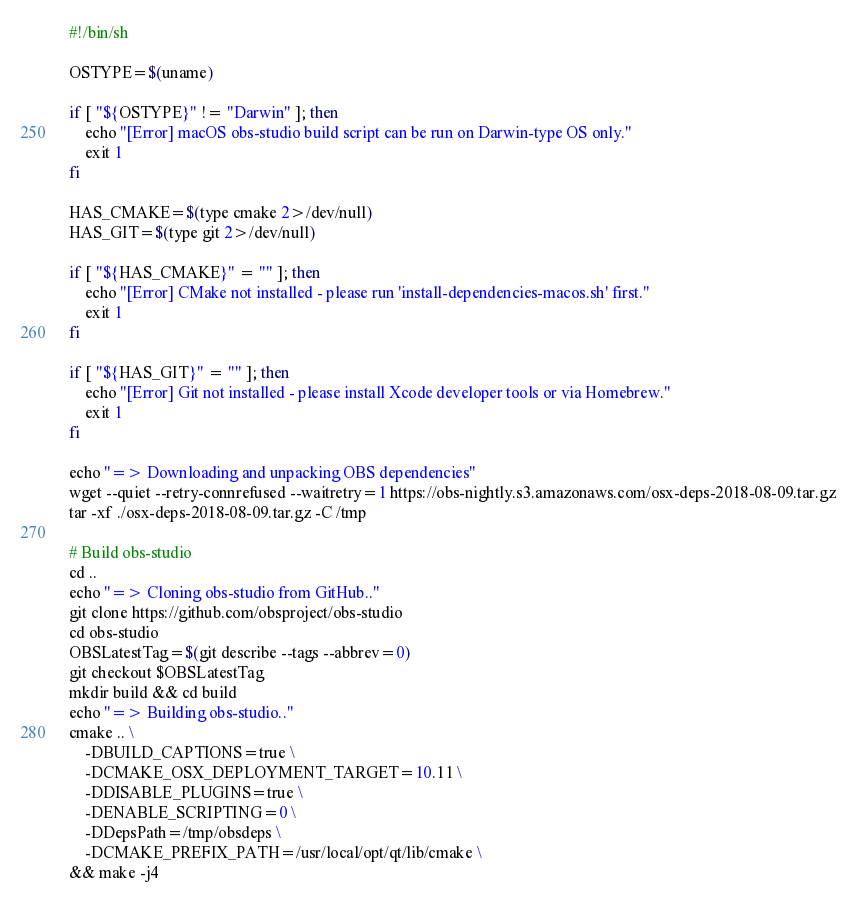<code> <loc_0><loc_0><loc_500><loc_500><_Bash_>#!/bin/sh

OSTYPE=$(uname)

if [ "${OSTYPE}" != "Darwin" ]; then
    echo "[Error] macOS obs-studio build script can be run on Darwin-type OS only."
    exit 1
fi

HAS_CMAKE=$(type cmake 2>/dev/null)
HAS_GIT=$(type git 2>/dev/null)

if [ "${HAS_CMAKE}" = "" ]; then
    echo "[Error] CMake not installed - please run 'install-dependencies-macos.sh' first."
    exit 1
fi

if [ "${HAS_GIT}" = "" ]; then
    echo "[Error] Git not installed - please install Xcode developer tools or via Homebrew."
    exit 1
fi

echo "=> Downloading and unpacking OBS dependencies"
wget --quiet --retry-connrefused --waitretry=1 https://obs-nightly.s3.amazonaws.com/osx-deps-2018-08-09.tar.gz
tar -xf ./osx-deps-2018-08-09.tar.gz -C /tmp

# Build obs-studio
cd ..
echo "=> Cloning obs-studio from GitHub.."
git clone https://github.com/obsproject/obs-studio
cd obs-studio
OBSLatestTag=$(git describe --tags --abbrev=0)
git checkout $OBSLatestTag
mkdir build && cd build
echo "=> Building obs-studio.."
cmake .. \
	-DBUILD_CAPTIONS=true \
	-DCMAKE_OSX_DEPLOYMENT_TARGET=10.11 \
	-DDISABLE_PLUGINS=true \
    -DENABLE_SCRIPTING=0 \
	-DDepsPath=/tmp/obsdeps \
	-DCMAKE_PREFIX_PATH=/usr/local/opt/qt/lib/cmake \
&& make -j4
</code> 